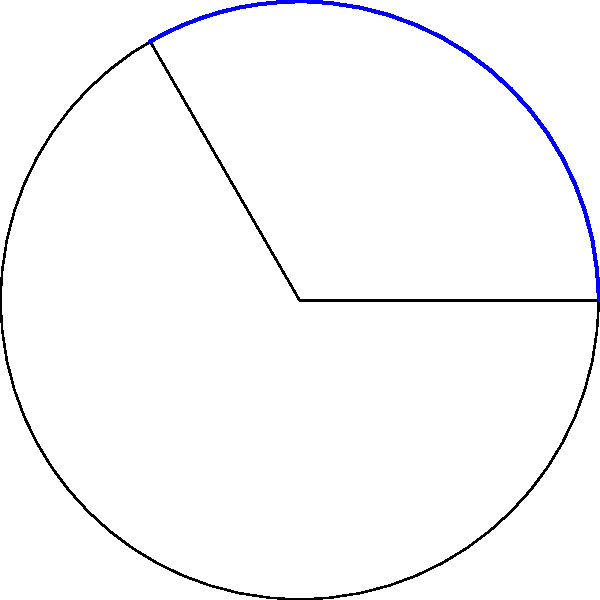In a circular telemarketing compliance zone, the radius represents the maximum call distance allowed by law, which is 30 miles. A sector of this zone, with a central angle of 120°, represents an area where specific regulations apply. Calculate the area of this sector to determine the coverage of these regulations. Round your answer to the nearest square mile. To solve this problem, we'll use the formula for the area of a circular sector:

$$ A = \frac{1}{2} r^2 \theta $$

Where:
- $A$ is the area of the sector
- $r$ is the radius of the circle
- $\theta$ is the central angle in radians

Step 1: Convert the angle from degrees to radians
$$ \theta = 120° \times \frac{\pi}{180°} = \frac{2\pi}{3} \text{ radians} $$

Step 2: Substitute the values into the formula
$$ A = \frac{1}{2} \times 30^2 \times \frac{2\pi}{3} $$

Step 3: Calculate
$$ A = \frac{1}{2} \times 900 \times \frac{2\pi}{3} = 300\pi $$

Step 4: Calculate the final value and round to the nearest square mile
$$ A \approx 942.48 \text{ sq miles} $$

Rounding to the nearest square mile gives us 942 sq miles.
Answer: 942 sq miles 